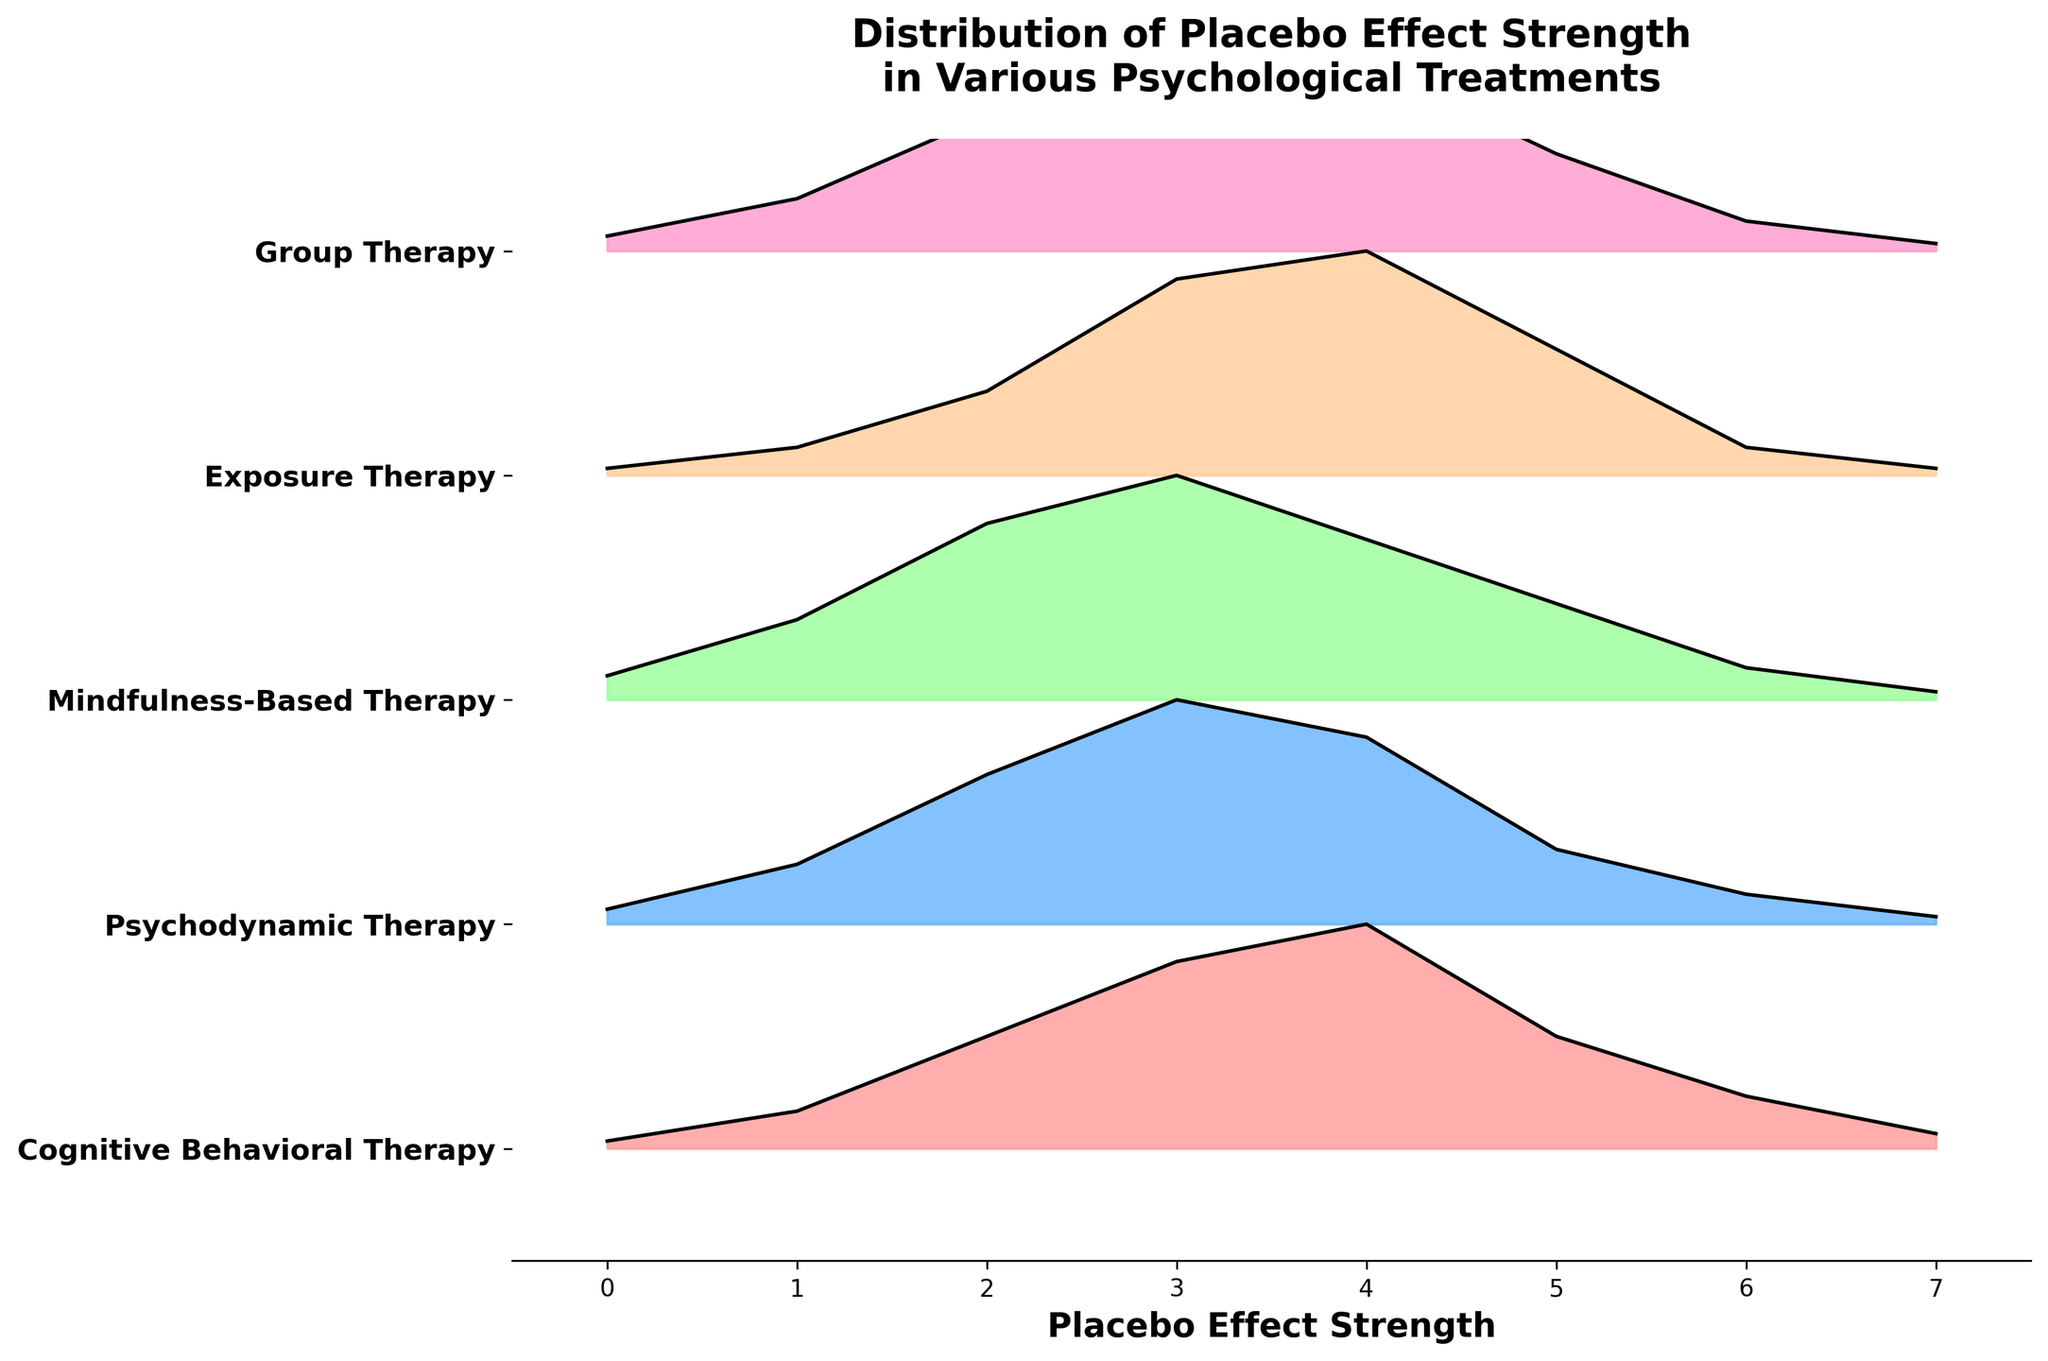What is the title of the figure? The title is located at the top of the figure and summarizes the main topic being visualized.
Answer: Distribution of Placebo Effect Strength in Various Psychological Treatments How many types of psychological treatments are visualized in the plot? Count the number of unique treatment labels on the y-axis.
Answer: 5 What is the treatment with the highest density at Placebo Effect Strength 4? Look for the peak values at Placebo Effect Strength 4 across all treatments.
Answer: Exposure Therapy Which treatment shows the broadest distribution in placebo effect strength? Compare the width of the density curves for each treatment.
Answer: Mindfulness-Based Therapy At which Placebo Effect Strength does Cognitive Behavioral Therapy have its highest density? Find the highest peak within the distribution curve for Cognitive Behavioral Therapy.
Answer: 4 Which treatment has the steepest decline in density after its highest peak? Identify the treatment with the sharpest drop in density values after reaching its highest value.
Answer: Cognitive Behavioral Therapy Compare the density values of Psychodynamic Therapy and Group Therapy at Placebo Effect Strength 3. Which is higher? Look at the density values on the plot for both therapies at Placebo Effect Strength 3 and compare them.
Answer: Group Therapy What is the Placebo Effect Strength range for Mindfulness-Based Therapy where the density is greater than 0.2? Identify the range in the plot where the density curve for Mindfulness-Based Therapy remains above 0.2.
Answer: 2 to 3.5 If you average the densities of all treatments at Placebo Effect Strength 5, what is the average density? Add the densities from each treatment at Placebo Effect Strength 5 and divide by the number of treatments.
Answer: 0.13 Which treatment has the lowest maximum density? Determine the peak density for each treatment and identify the lowest peak.
Answer: Exposure Therapy 